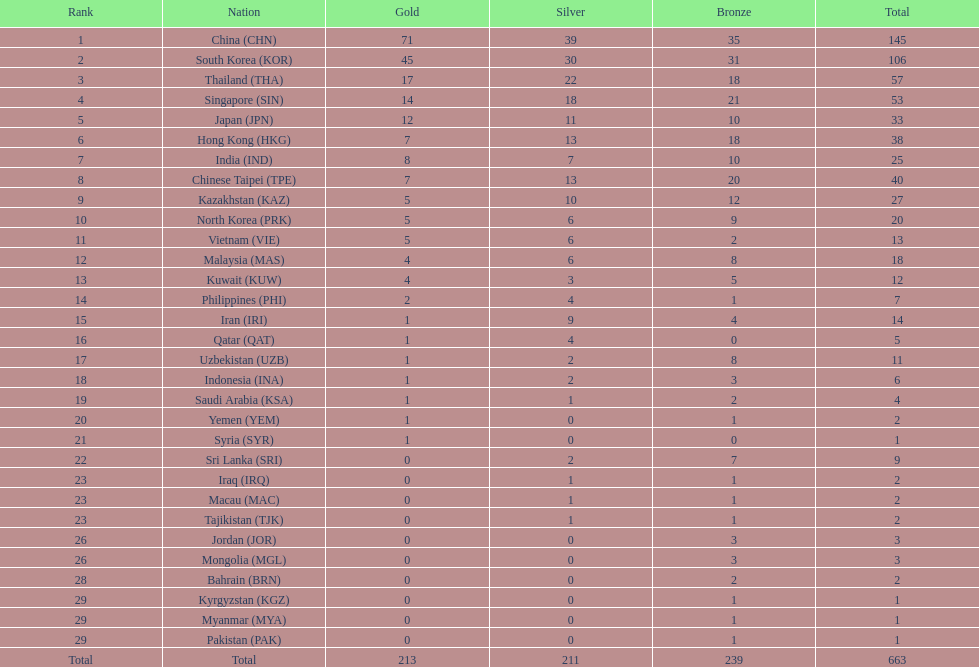What is the difference between the total amount of medals won by qatar and indonesia? 1. 